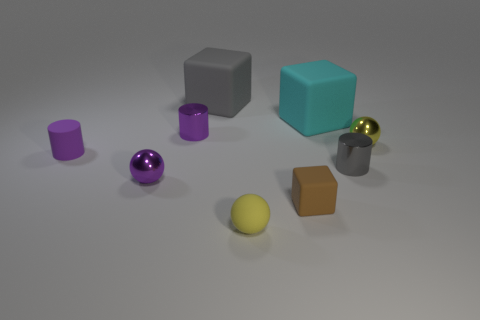Add 1 brown things. How many objects exist? 10 Subtract all cylinders. How many objects are left? 6 Subtract all purple metallic spheres. Subtract all balls. How many objects are left? 5 Add 1 yellow matte objects. How many yellow matte objects are left? 2 Add 9 large cyan rubber cubes. How many large cyan rubber cubes exist? 10 Subtract 0 blue balls. How many objects are left? 9 